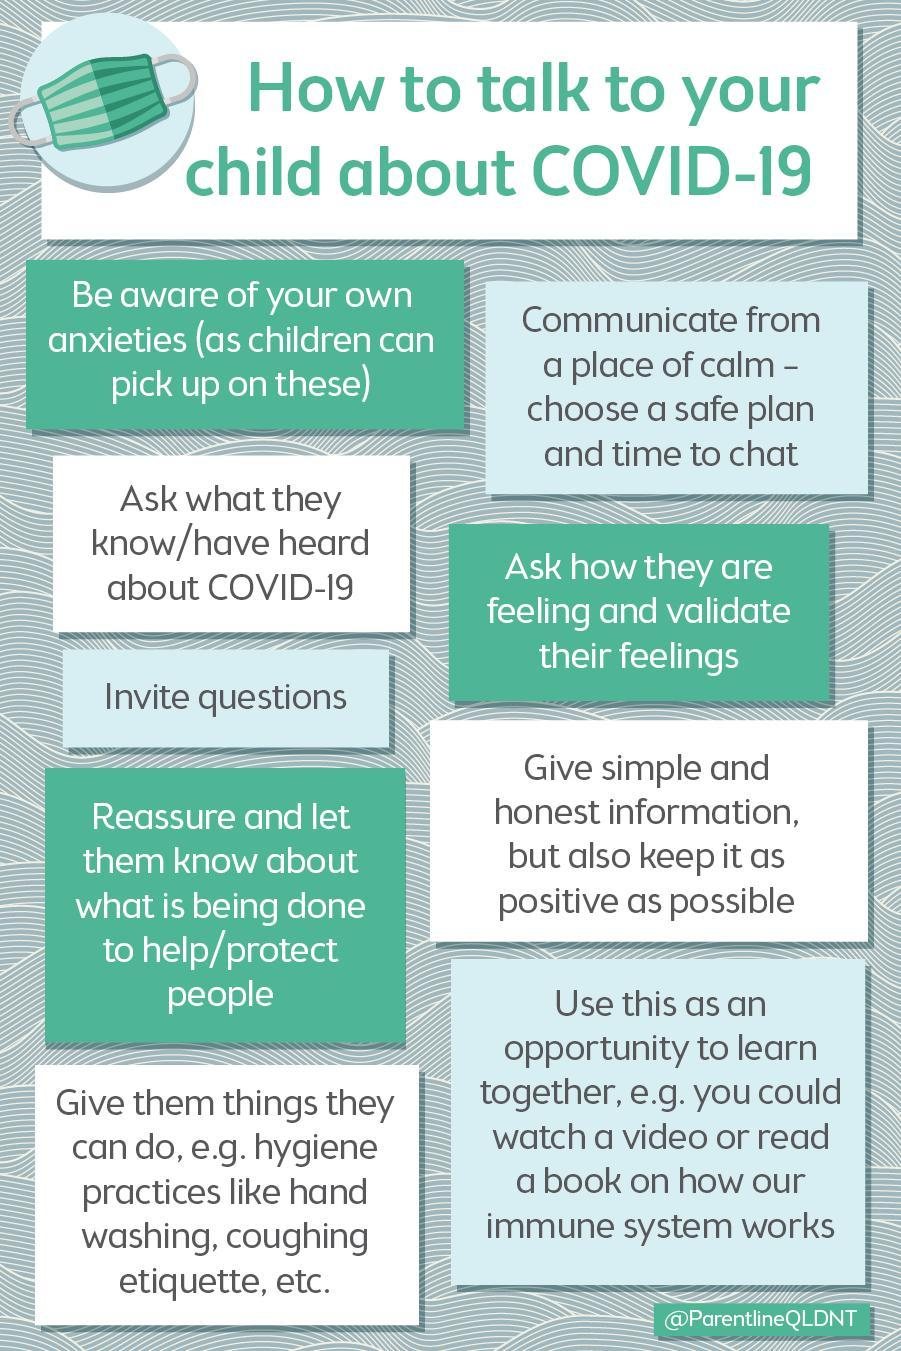How many points are discussed?
Answer the question with a short phrase. 9 